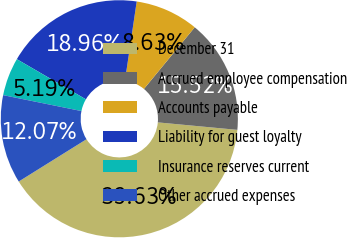Convert chart to OTSL. <chart><loc_0><loc_0><loc_500><loc_500><pie_chart><fcel>December 31<fcel>Accrued employee compensation<fcel>Accounts payable<fcel>Liability for guest loyalty<fcel>Insurance reserves current<fcel>Other accrued expenses<nl><fcel>39.63%<fcel>15.52%<fcel>8.63%<fcel>18.96%<fcel>5.19%<fcel>12.07%<nl></chart> 